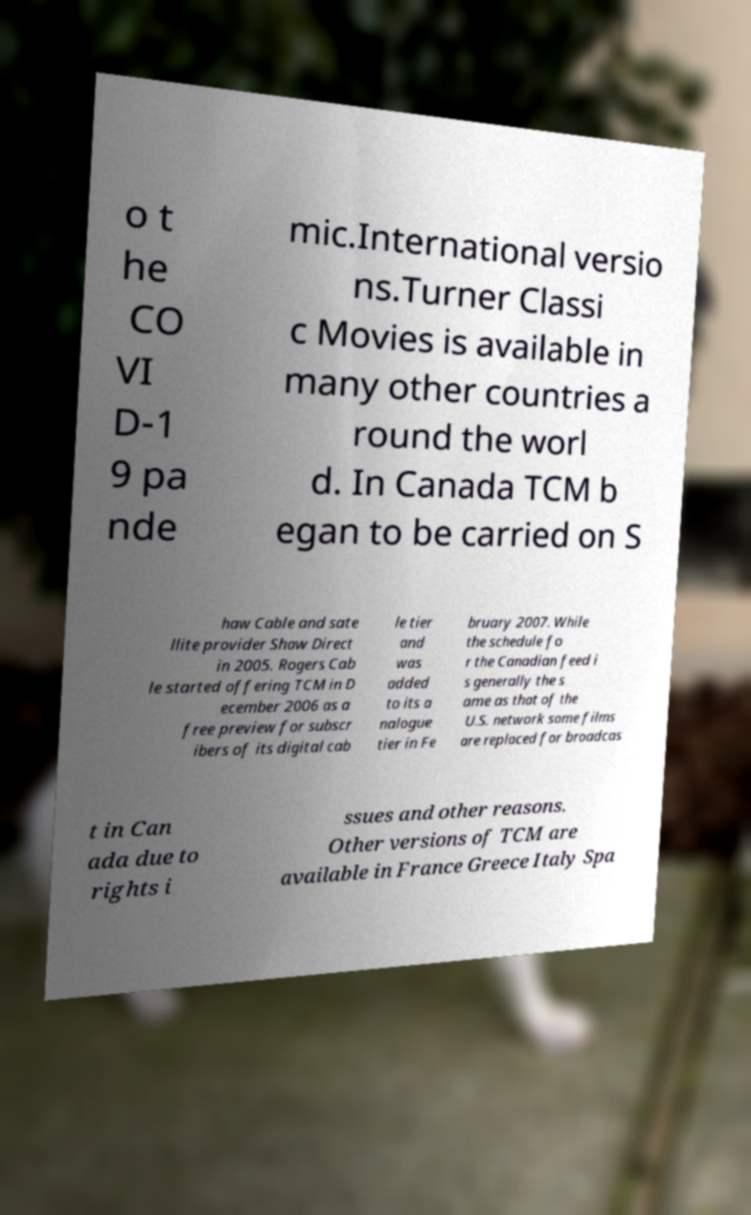Can you accurately transcribe the text from the provided image for me? o t he CO VI D-1 9 pa nde mic.International versio ns.Turner Classi c Movies is available in many other countries a round the worl d. In Canada TCM b egan to be carried on S haw Cable and sate llite provider Shaw Direct in 2005. Rogers Cab le started offering TCM in D ecember 2006 as a free preview for subscr ibers of its digital cab le tier and was added to its a nalogue tier in Fe bruary 2007. While the schedule fo r the Canadian feed i s generally the s ame as that of the U.S. network some films are replaced for broadcas t in Can ada due to rights i ssues and other reasons. Other versions of TCM are available in France Greece Italy Spa 